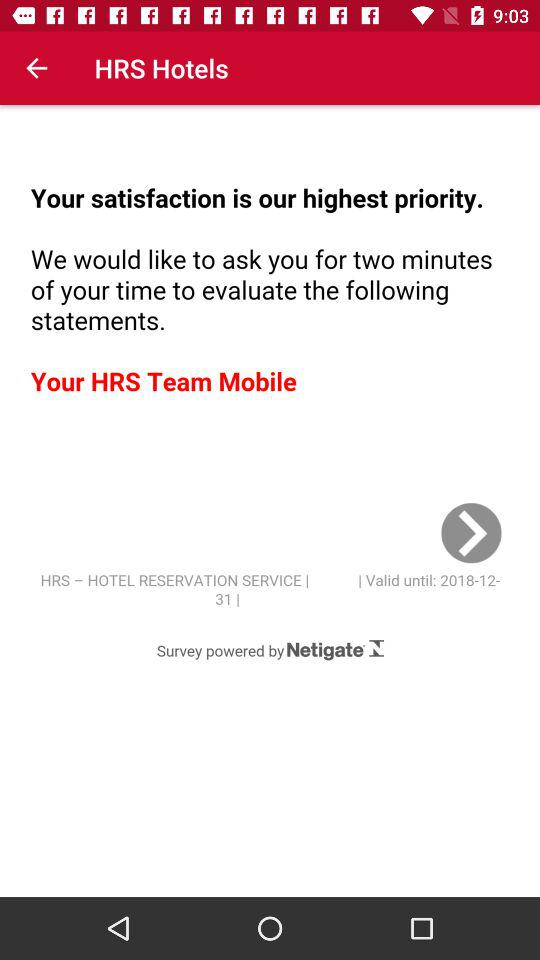What is the name of the application? The name of the application is "HRS Hotels". 